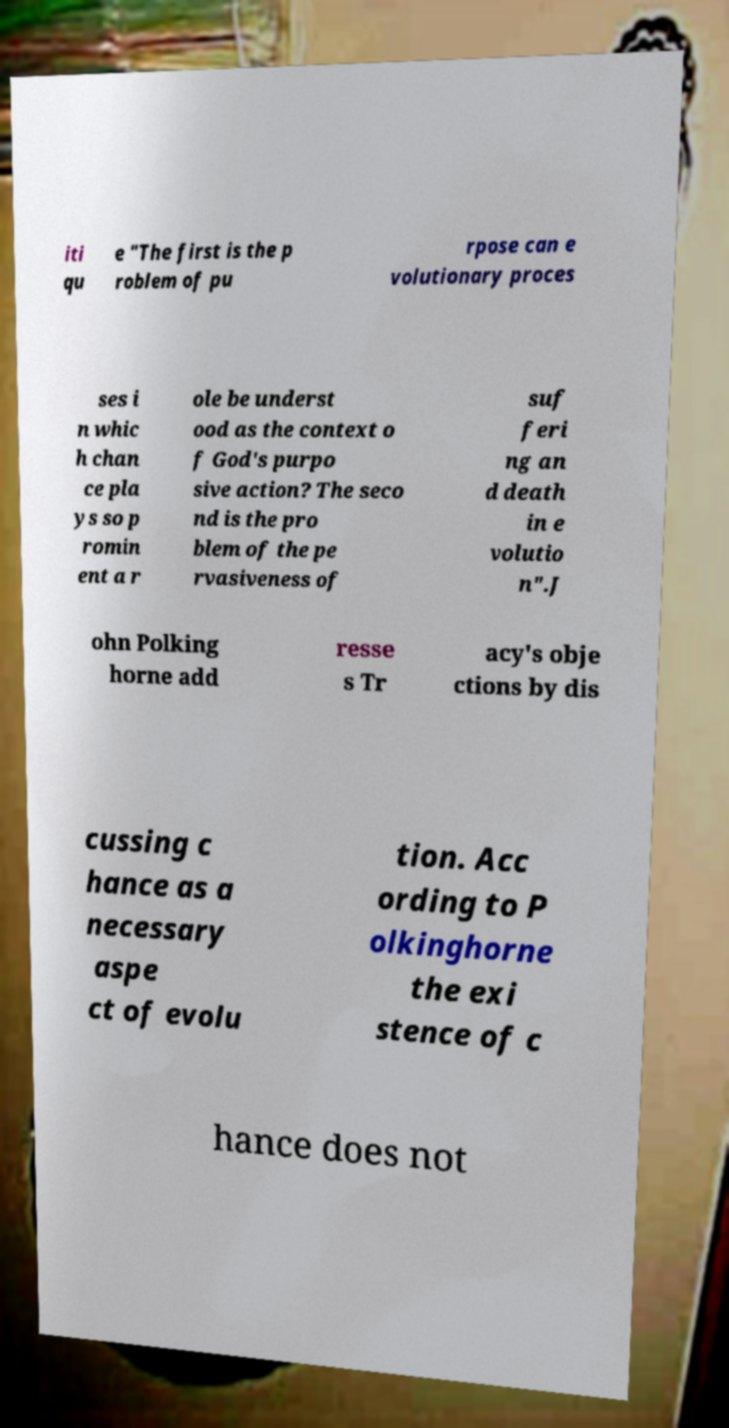What messages or text are displayed in this image? I need them in a readable, typed format. iti qu e "The first is the p roblem of pu rpose can e volutionary proces ses i n whic h chan ce pla ys so p romin ent a r ole be underst ood as the context o f God's purpo sive action? The seco nd is the pro blem of the pe rvasiveness of suf feri ng an d death in e volutio n".J ohn Polking horne add resse s Tr acy's obje ctions by dis cussing c hance as a necessary aspe ct of evolu tion. Acc ording to P olkinghorne the exi stence of c hance does not 